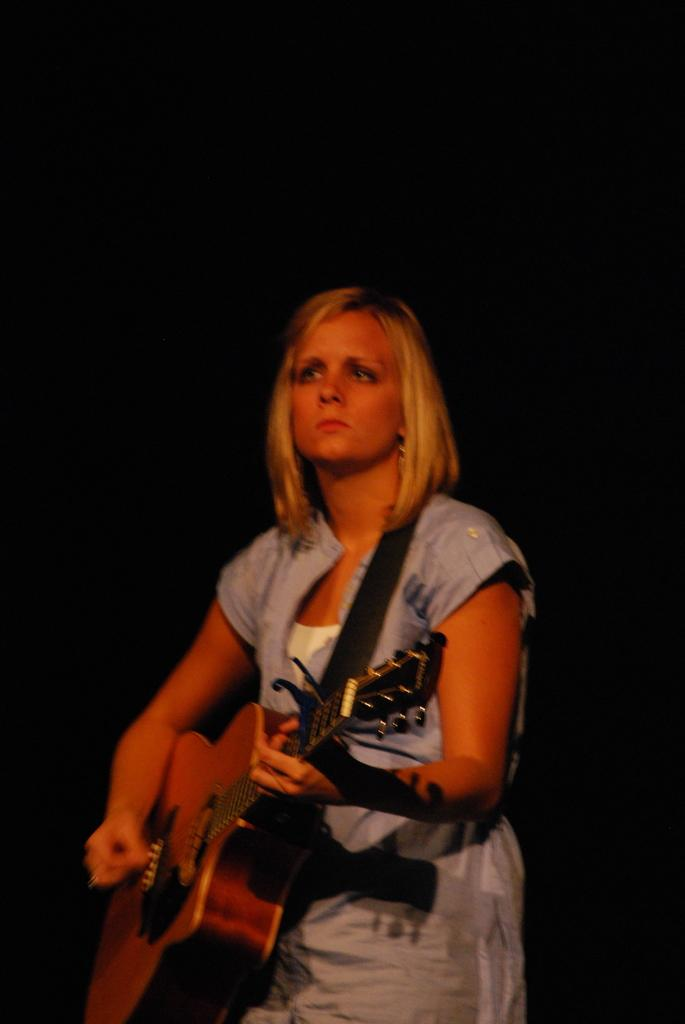What is the main subject of the image? The main subject of the image is a woman. What is the woman holding in the image? The woman is holding a guitar. What is the woman's facial expression in the image? The woman is staring seriously. What is the color of the woman's hair in the image? The woman has blond hair. What type of servant is standing next to the woman in the image? There is no servant present in the image; it only features a woman holding a guitar. 